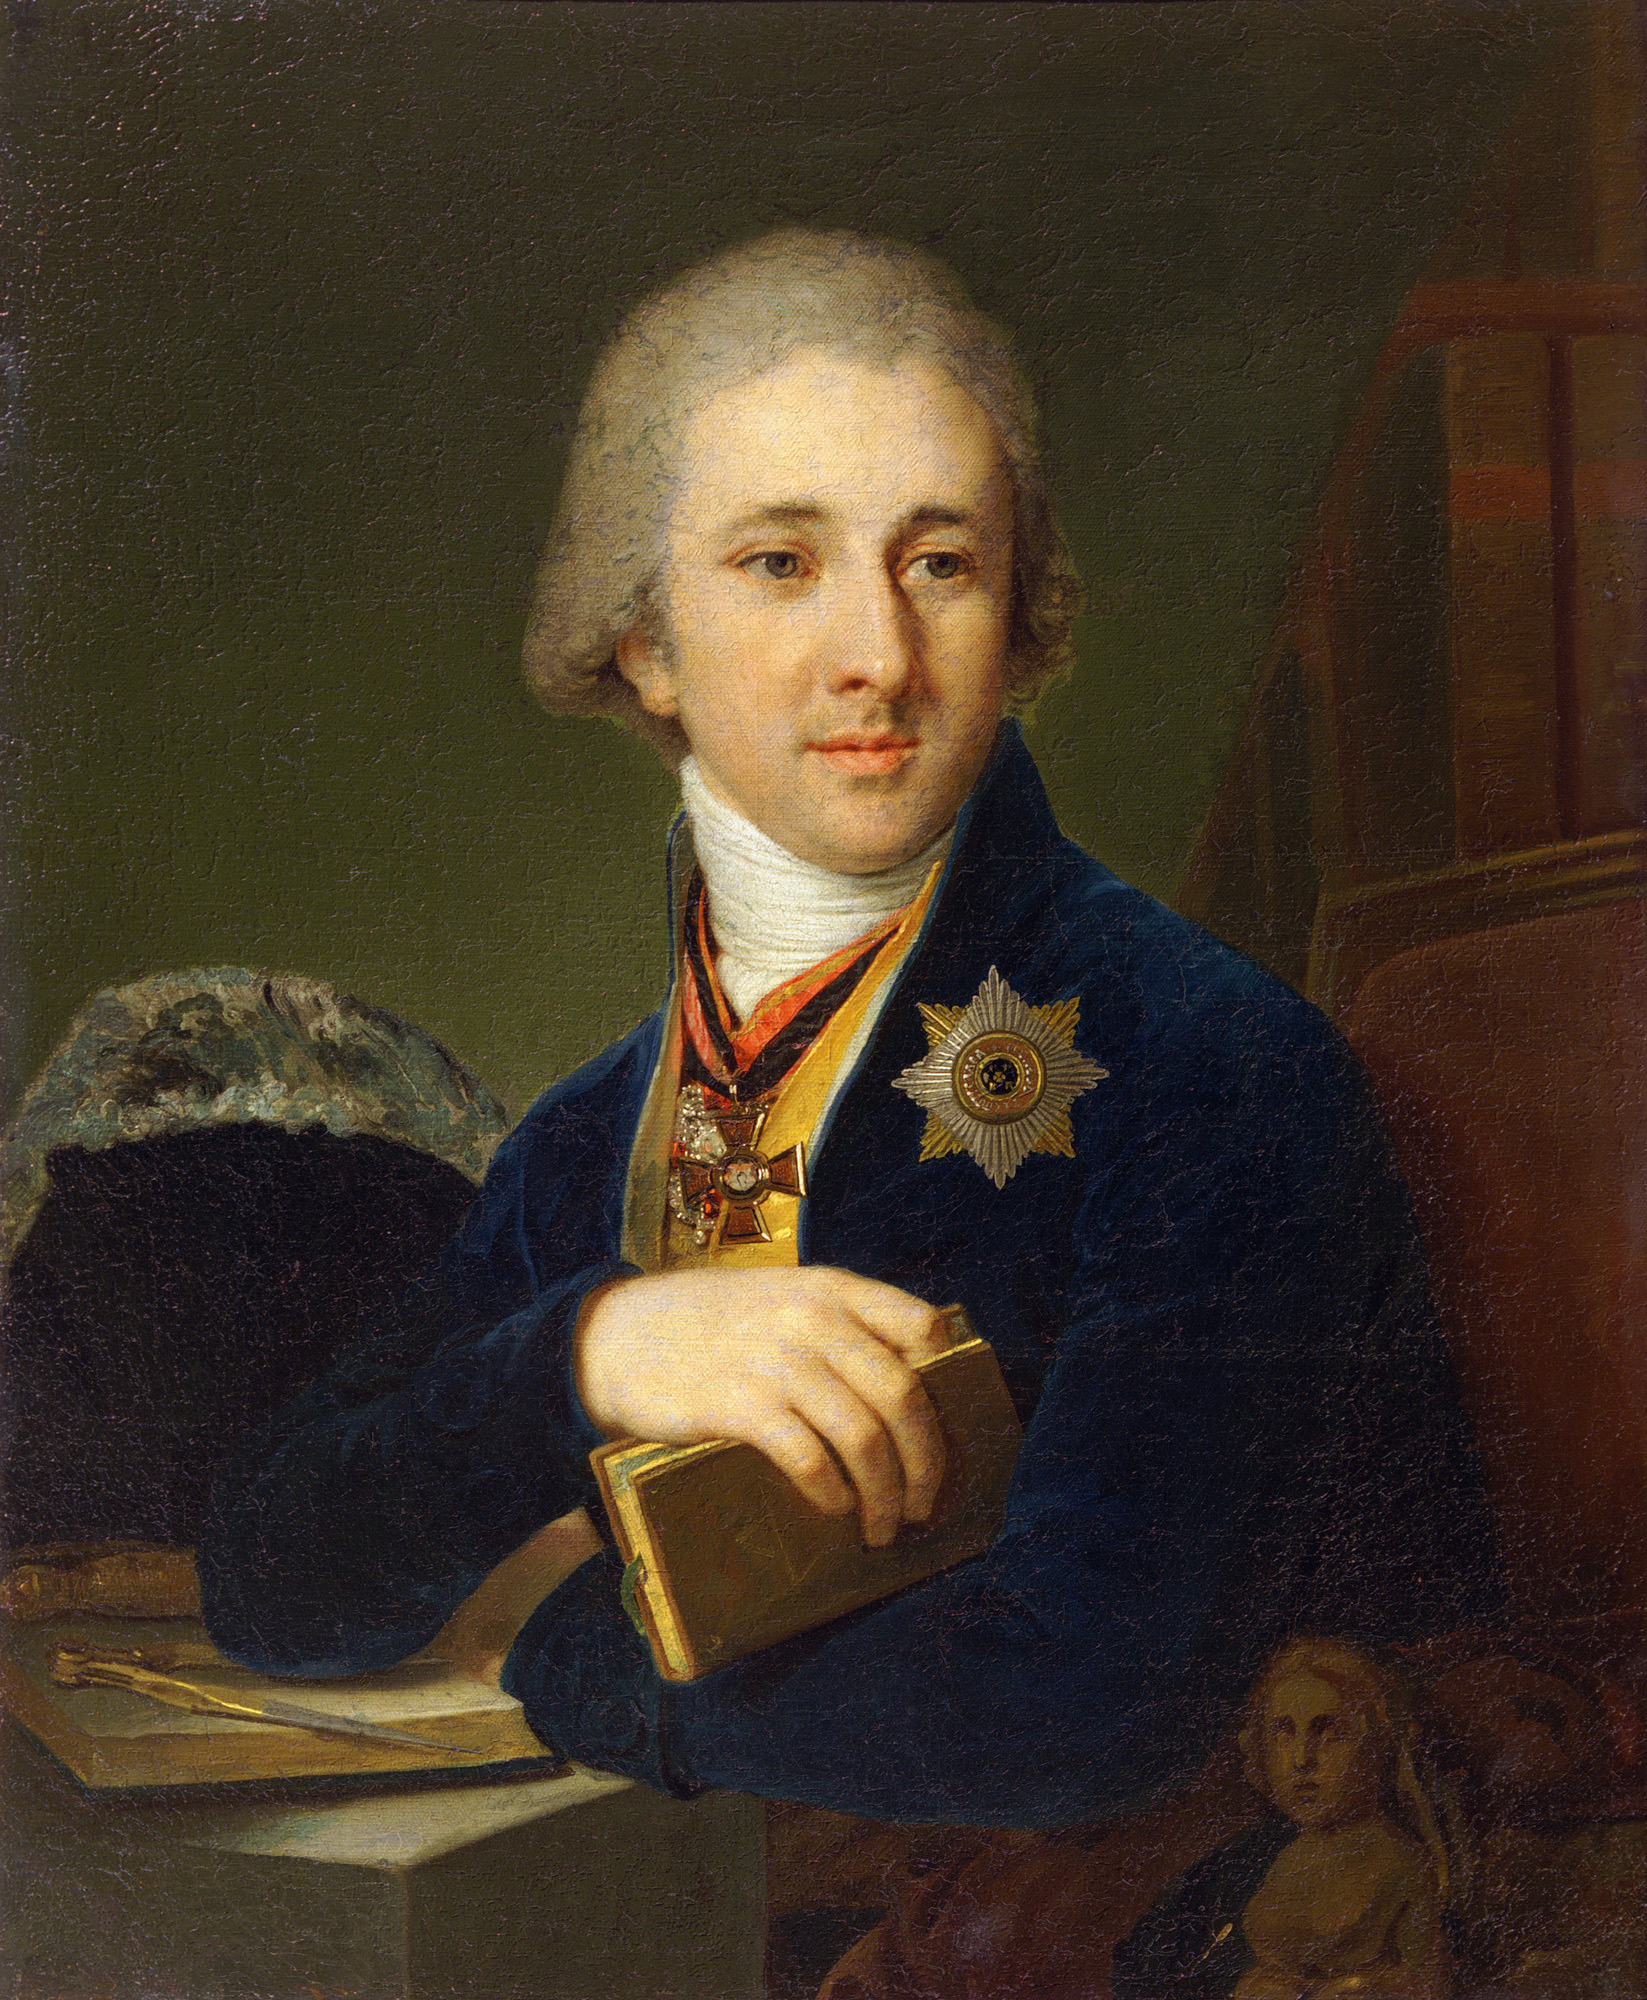What is this photo about? The image depicts a portrait of a distinguished man from the Enlightenment era. He is dressed in a formal blue coat with decorative badges, indicating a status of nobility or high societal rank. His attire, including the white powdered wig, aligns with 18th-century European fashion, suggesting he might be a scholar or a person of intellectual prominence, as further hinted by his casual hold on a book. The painting in the background, showing a woman, could denote personal significance or a common artistic practice of including meaningful relationships. The portrayal is rich in detail, suggesting the subject's importance and the artist's skill. 